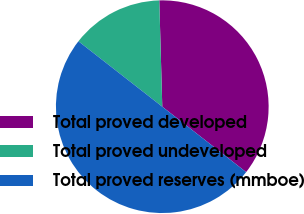<chart> <loc_0><loc_0><loc_500><loc_500><pie_chart><fcel>Total proved developed<fcel>Total proved undeveloped<fcel>Total proved reserves (mmboe)<nl><fcel>35.99%<fcel>14.01%<fcel>50.0%<nl></chart> 